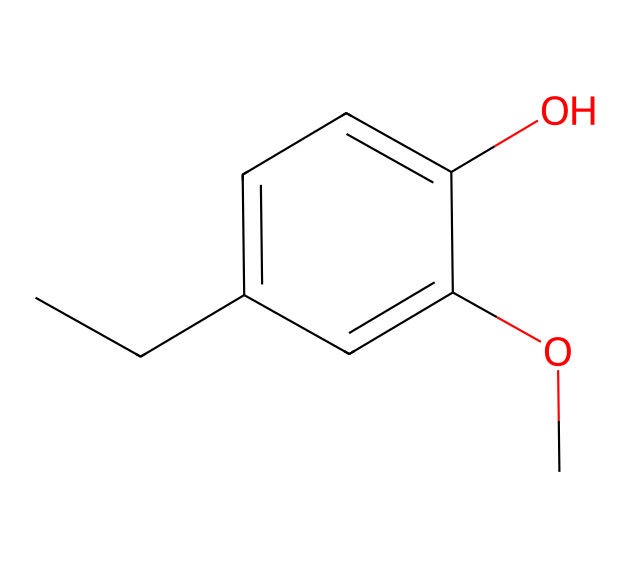What is the molecular formula of this compound? The SMILES representation indicates the presence of 10 carbon (C) atoms, 12 hydrogen (H) atoms, and 3 oxygen (O) atoms. Therefore, the molecular formula is C10H12O3.
Answer: C10H12O3 How many hydroxyl groups are present in the structure? By examining the structure, we can identify one hydroxyl (–OH) group attached to the aromatic ring. Thus, there is one hydroxyl group in this compound.
Answer: one What type of functional group is present in this molecule? The presence of the hydroxyl group (–OH) in the compound indicates that it has phenolic properties. Additionally, the methoxy group (–OCH3) is also present, which is another functional group.
Answer: phenolic What is the main aromatic system in this compound? The chemical structure shows a six-membered aromatic ring with alternating single and double bonds, characteristic of a phenyl group. Thus, the main aromatic system is a phenyl ring.
Answer: phenyl ring How many total rings are in this compound? Analyzing the structure reveals that there is only one aromatic ring present in the compound, confirming that the total number of rings is one.
Answer: one Does this compound contain any heteroatoms? The SMILES representation indicates that there are only carbon and oxygen atoms present, with no presence of heteroatoms like nitrogen or sulfur. Therefore, it contains no heteroatoms.
Answer: no 